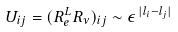Convert formula to latex. <formula><loc_0><loc_0><loc_500><loc_500>U _ { i j } = ( R ^ { L } _ { e } R _ { \nu } ) _ { i j } \sim \epsilon ^ { \, | l _ { i } - l _ { j } | }</formula> 